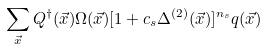<formula> <loc_0><loc_0><loc_500><loc_500>\sum _ { \vec { x } } Q ^ { \dagger } ( \vec { x } ) \Omega ( \vec { x } ) [ 1 + c _ { s } \Delta ^ { ( 2 ) } ( \vec { x } ) ] ^ { n _ { s } } q ( \vec { x } )</formula> 